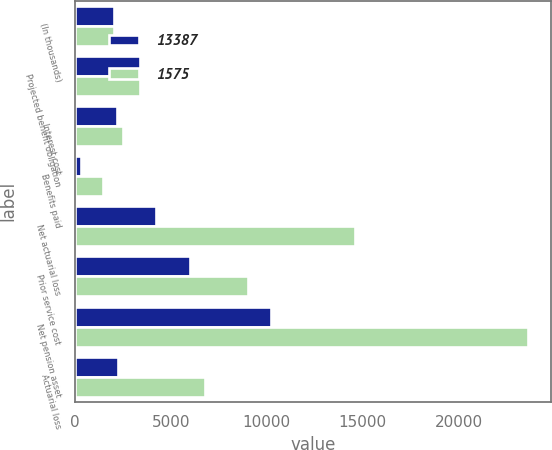<chart> <loc_0><loc_0><loc_500><loc_500><stacked_bar_chart><ecel><fcel>(In thousands)<fcel>Projected benefit obligation<fcel>Interest cost<fcel>Benefits paid<fcel>Net actuarial loss<fcel>Prior service cost<fcel>Net pension asset<fcel>Actuarial loss<nl><fcel>13387<fcel>2013<fcel>3359<fcel>2191<fcel>285<fcel>4242<fcel>5988<fcel>10230<fcel>2221<nl><fcel>1575<fcel>2012<fcel>3359<fcel>2476<fcel>1426<fcel>14605<fcel>9012<fcel>23617<fcel>6795<nl></chart> 